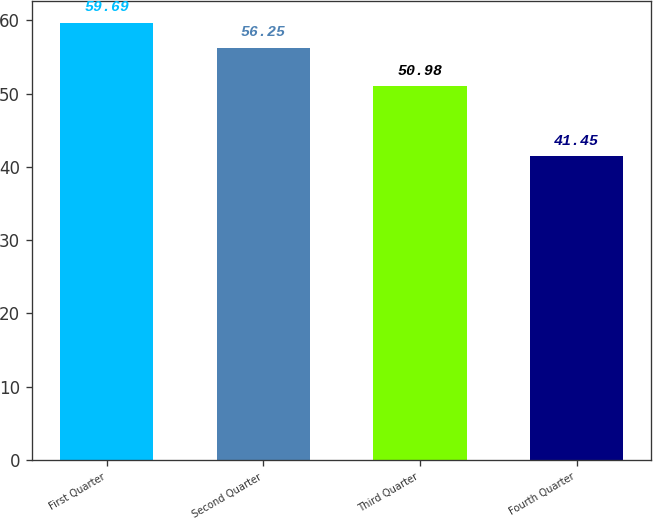Convert chart. <chart><loc_0><loc_0><loc_500><loc_500><bar_chart><fcel>First Quarter<fcel>Second Quarter<fcel>Third Quarter<fcel>Fourth Quarter<nl><fcel>59.69<fcel>56.25<fcel>50.98<fcel>41.45<nl></chart> 